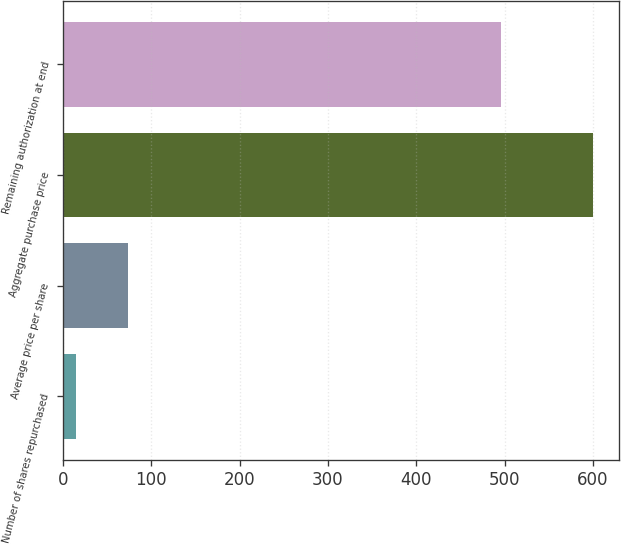<chart> <loc_0><loc_0><loc_500><loc_500><bar_chart><fcel>Number of shares repurchased<fcel>Average price per share<fcel>Aggregate purchase price<fcel>Remaining authorization at end<nl><fcel>14.6<fcel>73.14<fcel>600<fcel>496.3<nl></chart> 